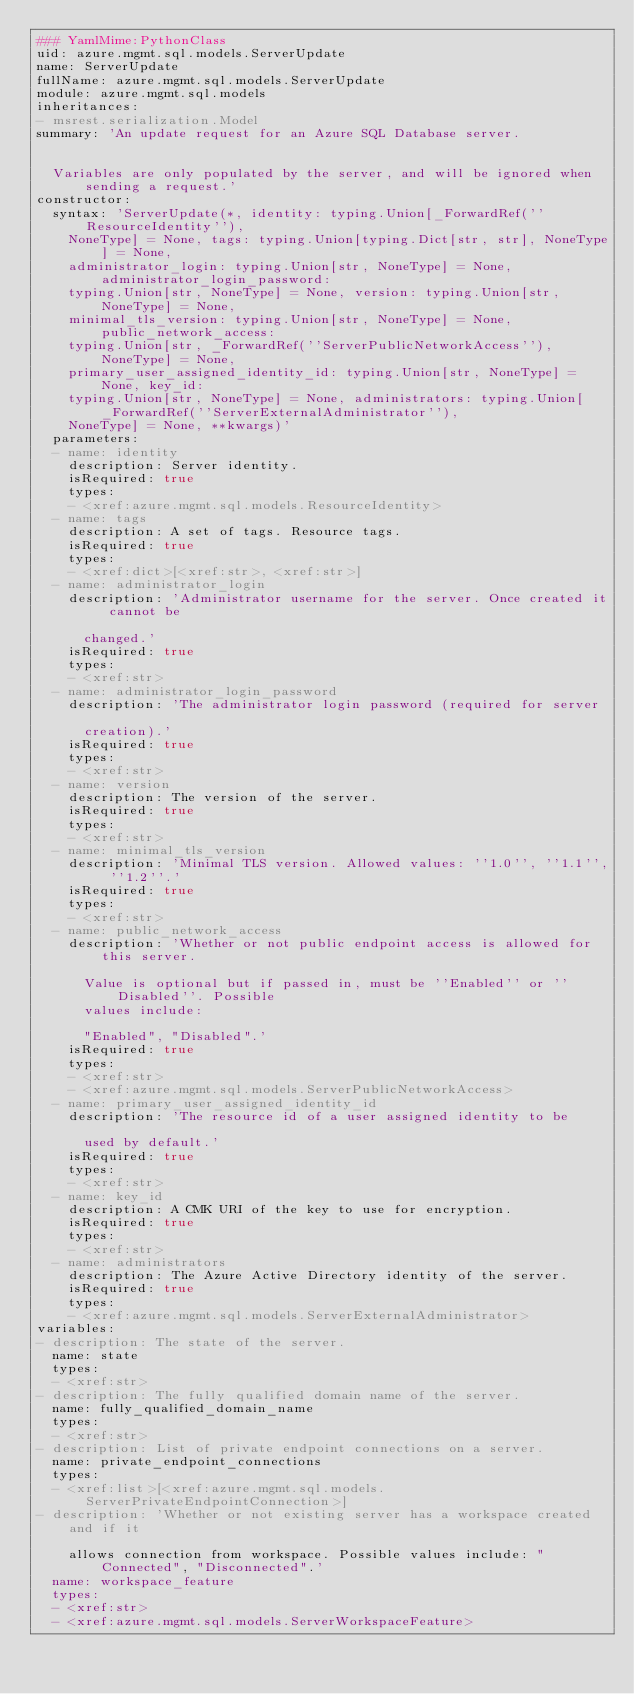<code> <loc_0><loc_0><loc_500><loc_500><_YAML_>### YamlMime:PythonClass
uid: azure.mgmt.sql.models.ServerUpdate
name: ServerUpdate
fullName: azure.mgmt.sql.models.ServerUpdate
module: azure.mgmt.sql.models
inheritances:
- msrest.serialization.Model
summary: 'An update request for an Azure SQL Database server.


  Variables are only populated by the server, and will be ignored when sending a request.'
constructor:
  syntax: 'ServerUpdate(*, identity: typing.Union[_ForwardRef(''ResourceIdentity''),
    NoneType] = None, tags: typing.Union[typing.Dict[str, str], NoneType] = None,
    administrator_login: typing.Union[str, NoneType] = None, administrator_login_password:
    typing.Union[str, NoneType] = None, version: typing.Union[str, NoneType] = None,
    minimal_tls_version: typing.Union[str, NoneType] = None, public_network_access:
    typing.Union[str, _ForwardRef(''ServerPublicNetworkAccess''), NoneType] = None,
    primary_user_assigned_identity_id: typing.Union[str, NoneType] = None, key_id:
    typing.Union[str, NoneType] = None, administrators: typing.Union[_ForwardRef(''ServerExternalAdministrator''),
    NoneType] = None, **kwargs)'
  parameters:
  - name: identity
    description: Server identity.
    isRequired: true
    types:
    - <xref:azure.mgmt.sql.models.ResourceIdentity>
  - name: tags
    description: A set of tags. Resource tags.
    isRequired: true
    types:
    - <xref:dict>[<xref:str>, <xref:str>]
  - name: administrator_login
    description: 'Administrator username for the server. Once created it cannot be

      changed.'
    isRequired: true
    types:
    - <xref:str>
  - name: administrator_login_password
    description: 'The administrator login password (required for server

      creation).'
    isRequired: true
    types:
    - <xref:str>
  - name: version
    description: The version of the server.
    isRequired: true
    types:
    - <xref:str>
  - name: minimal_tls_version
    description: 'Minimal TLS version. Allowed values: ''1.0'', ''1.1'', ''1.2''.'
    isRequired: true
    types:
    - <xref:str>
  - name: public_network_access
    description: 'Whether or not public endpoint access is allowed for this server.

      Value is optional but if passed in, must be ''Enabled'' or ''Disabled''. Possible
      values include:

      "Enabled", "Disabled".'
    isRequired: true
    types:
    - <xref:str>
    - <xref:azure.mgmt.sql.models.ServerPublicNetworkAccess>
  - name: primary_user_assigned_identity_id
    description: 'The resource id of a user assigned identity to be

      used by default.'
    isRequired: true
    types:
    - <xref:str>
  - name: key_id
    description: A CMK URI of the key to use for encryption.
    isRequired: true
    types:
    - <xref:str>
  - name: administrators
    description: The Azure Active Directory identity of the server.
    isRequired: true
    types:
    - <xref:azure.mgmt.sql.models.ServerExternalAdministrator>
variables:
- description: The state of the server.
  name: state
  types:
  - <xref:str>
- description: The fully qualified domain name of the server.
  name: fully_qualified_domain_name
  types:
  - <xref:str>
- description: List of private endpoint connections on a server.
  name: private_endpoint_connections
  types:
  - <xref:list>[<xref:azure.mgmt.sql.models.ServerPrivateEndpointConnection>]
- description: 'Whether or not existing server has a workspace created and if it

    allows connection from workspace. Possible values include: "Connected", "Disconnected".'
  name: workspace_feature
  types:
  - <xref:str>
  - <xref:azure.mgmt.sql.models.ServerWorkspaceFeature>
</code> 